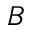<formula> <loc_0><loc_0><loc_500><loc_500>B</formula> 